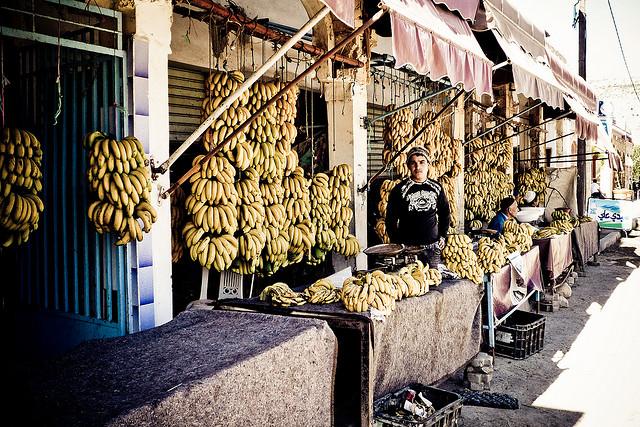Is the guy selling oranges?
Concise answer only. No. What fruit is hanging?
Quick response, please. Bananas. Are the bananas ripe?
Give a very brief answer. Yes. 